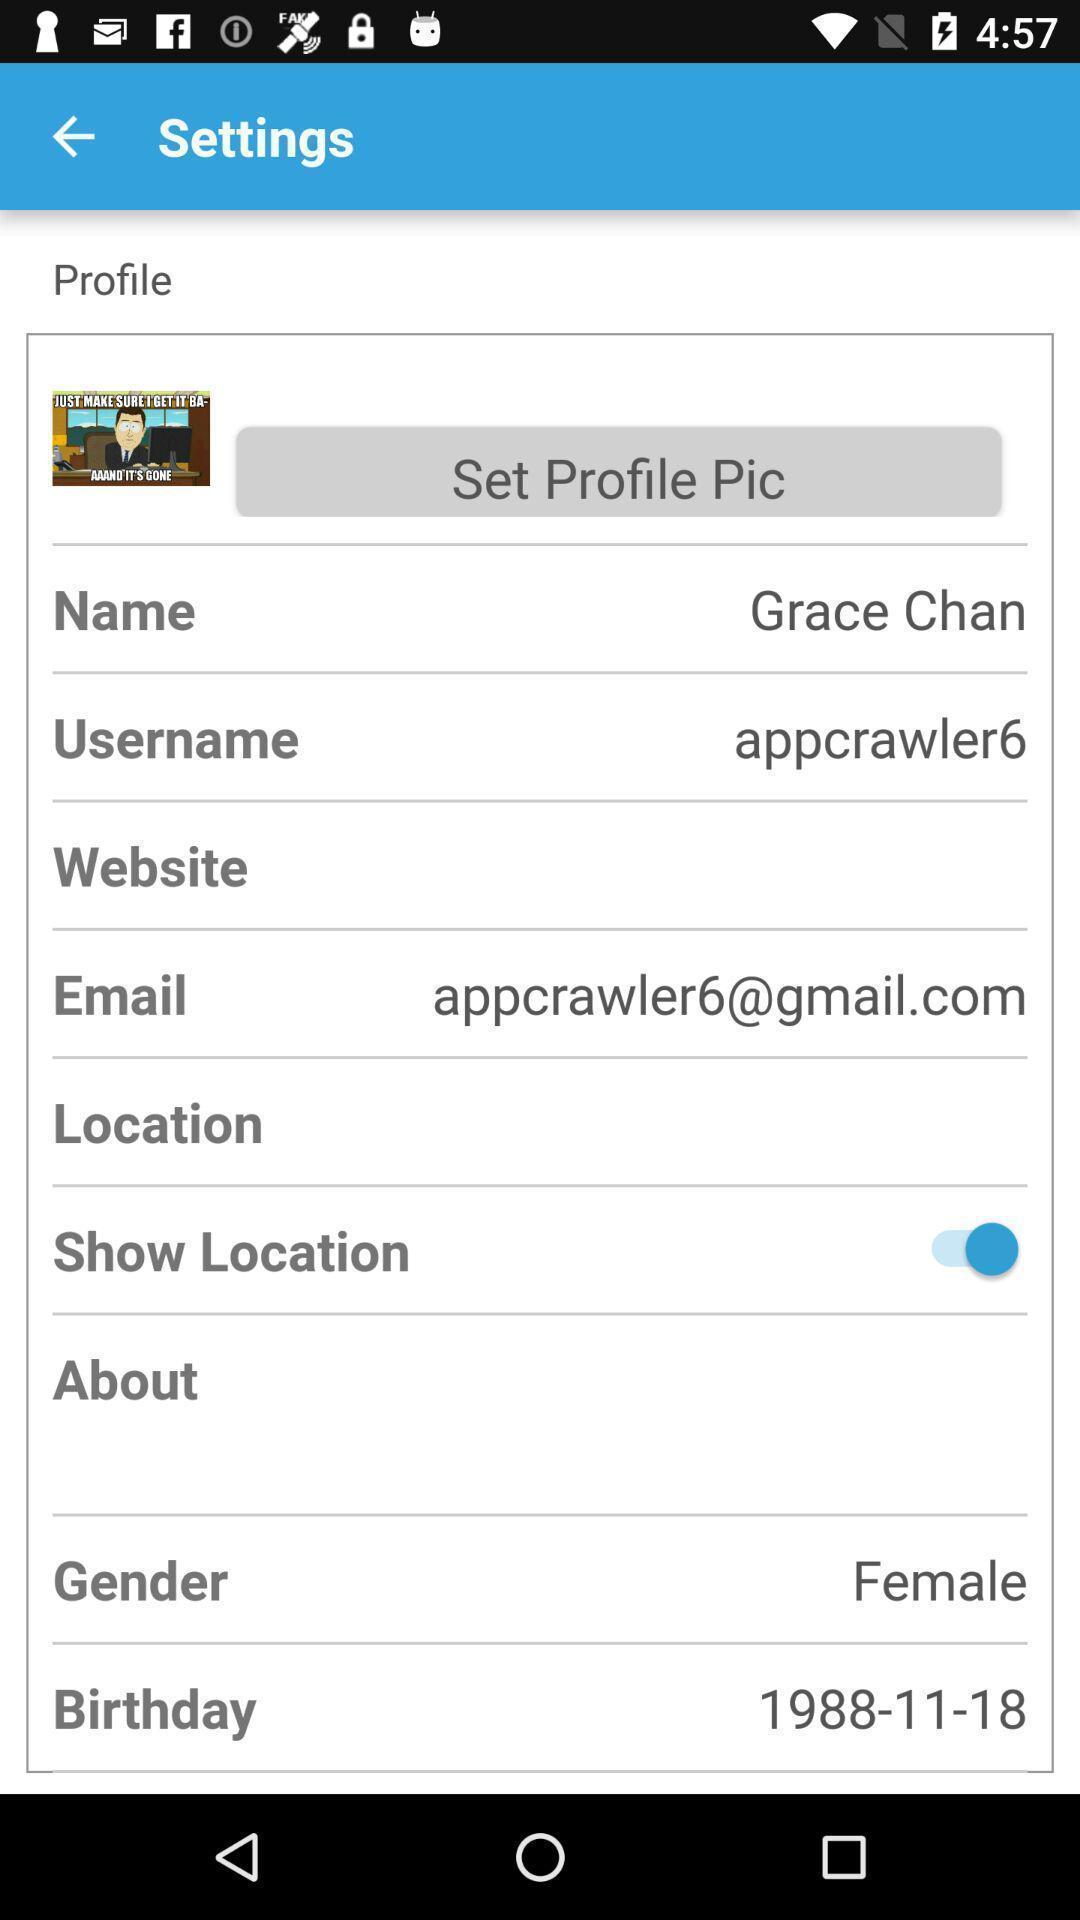What is the overall content of this screenshot? Setting page displaying the various options. 